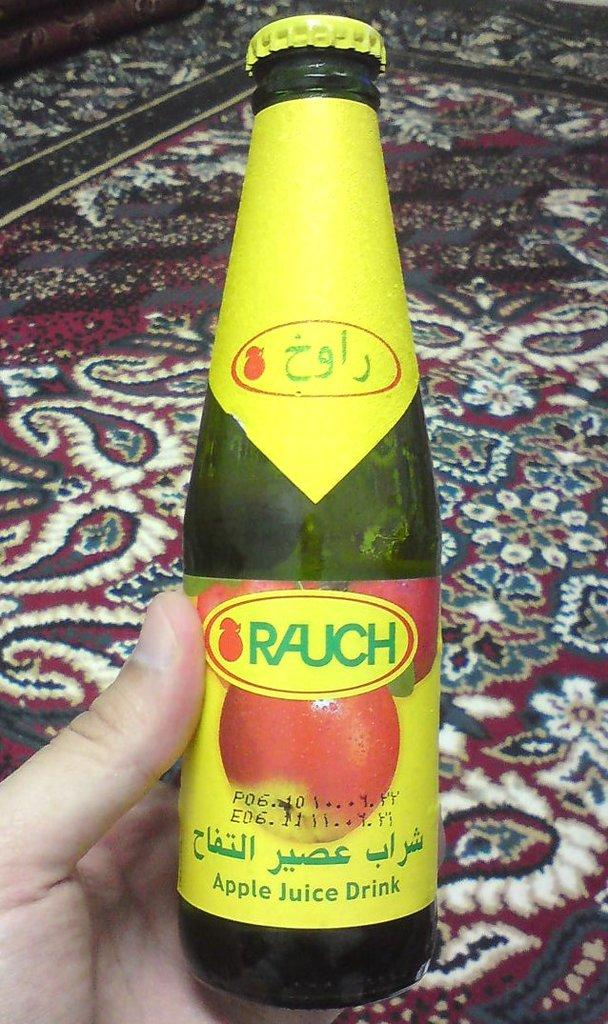<image>
Create a compact narrative representing the image presented. A bottle of apple juice drink has a bright yellow label. 